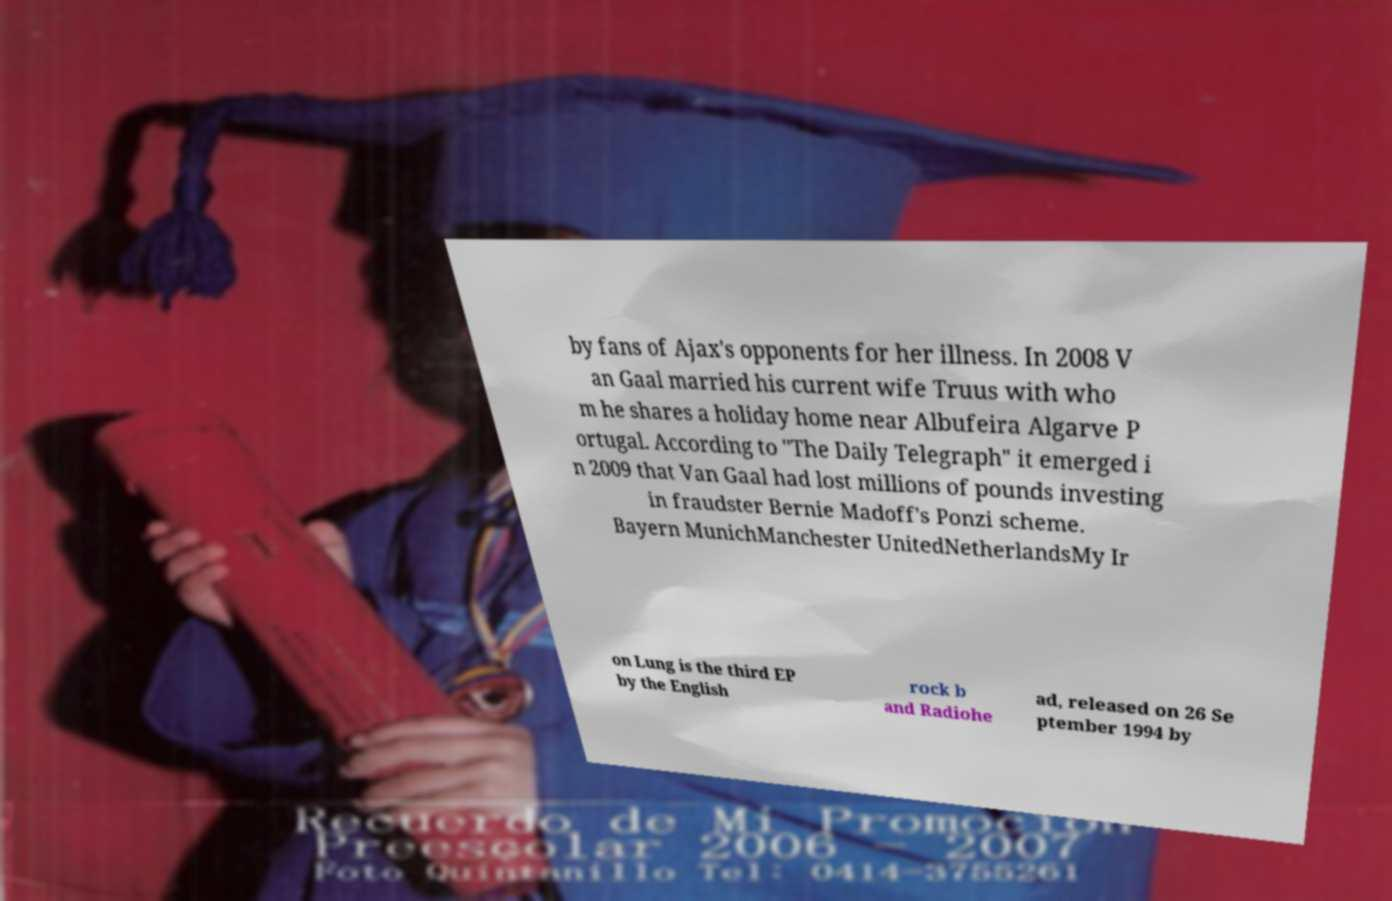Please identify and transcribe the text found in this image. by fans of Ajax's opponents for her illness. In 2008 V an Gaal married his current wife Truus with who m he shares a holiday home near Albufeira Algarve P ortugal. According to "The Daily Telegraph" it emerged i n 2009 that Van Gaal had lost millions of pounds investing in fraudster Bernie Madoff's Ponzi scheme. Bayern MunichManchester UnitedNetherlandsMy Ir on Lung is the third EP by the English rock b and Radiohe ad, released on 26 Se ptember 1994 by 